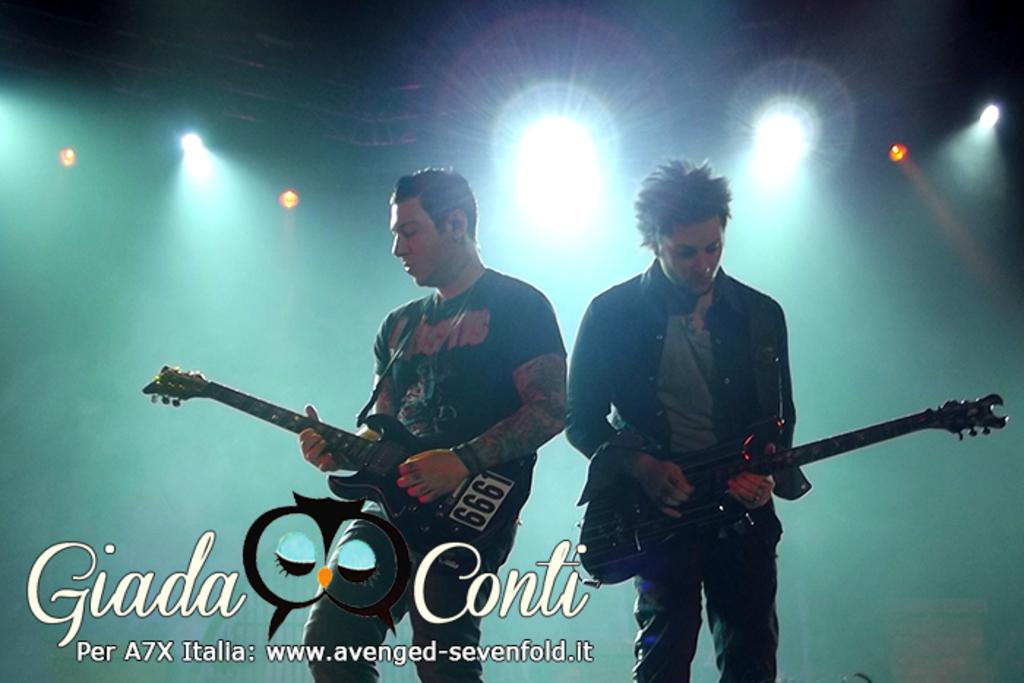How many people are in the image? There are two men in the image. What are the men doing in the image? The men are standing and playing guitars. What can be seen in the background of the image? There are lights visible in the background of the image. What type of expert advice can be heard from the men in the image? There is no indication in the image that the men are providing expert advice or that any audio is present. 